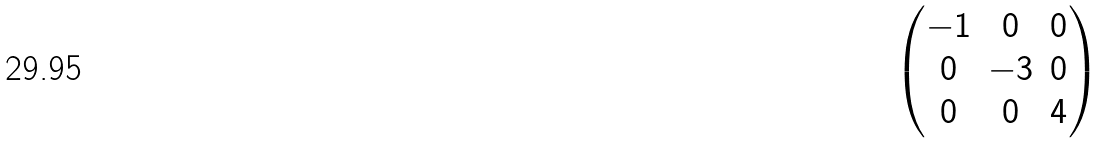Convert formula to latex. <formula><loc_0><loc_0><loc_500><loc_500>\begin{pmatrix} - 1 & 0 & 0 \\ 0 & - 3 & 0 \\ 0 & 0 & 4 \\ \end{pmatrix}</formula> 